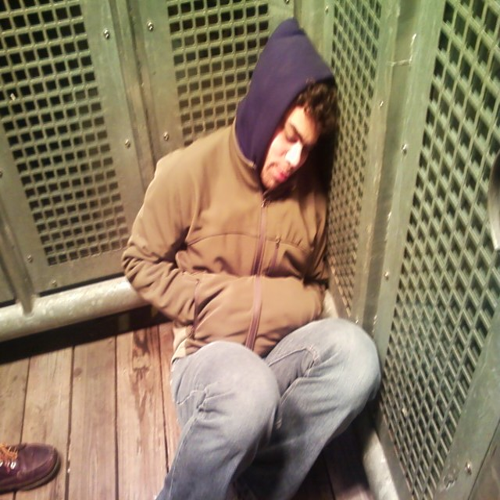Are there any noise artifacts in the image? Upon close examination, the image appears to be of sufficient quality without noticeable noise artifacts. It's clear and well captured, without any apparent visual distortions or speckles that would indicate digital noise. 